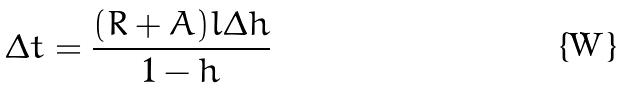<formula> <loc_0><loc_0><loc_500><loc_500>\Delta t = \frac { ( R + A ) l \Delta h } { 1 - h }</formula> 